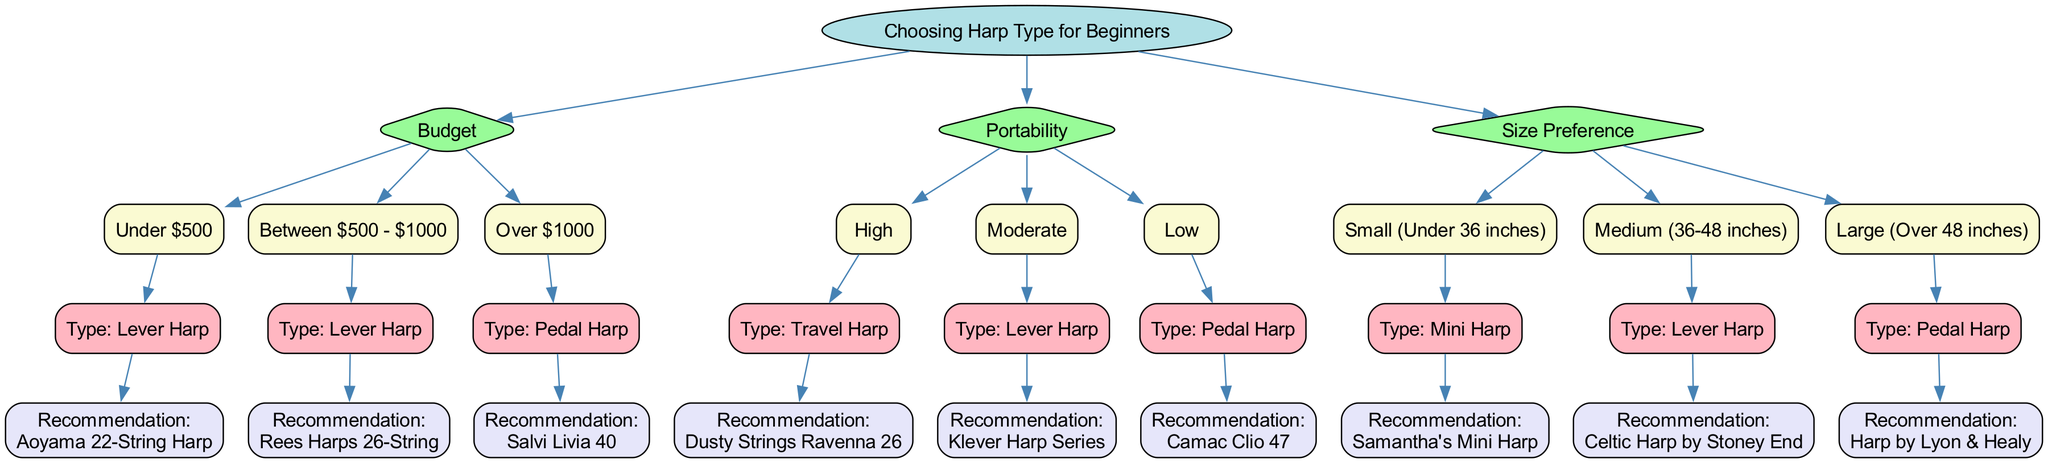What types of harps are recommended for a budget under $500? In the diagram under the "Budget" category, the subcategory "Under $500" leads to the "Lever Harp" type. The recommendation given is the "Aoyama 22-String Harp."
Answer: Lever Harp, Aoyama 22-String Harp What should I choose if I want a highly portable harp? Within the "Portability" category, the "High" subcategory leads to the "Travel Harp" type, and the recommendation is the "Dusty Strings Ravenna 26."
Answer: Travel Harp, Dusty Strings Ravenna 26 How many main categories are there in this decision tree? The diagram starts with the root and has three main categories: "Budget," "Portability," and "Size Preference." Thus, there are three main categories total.
Answer: 3 If I have a size preference of "Large (Over 48 inches)," what type of harp will I get? Looking at the "Size Preference" category, the subcategory "Large (Over 48 inches)" leads to the "Pedal Harp" type, with the recommendation being "Harp by Lyon & Healy."
Answer: Pedal Harp, Harp by Lyon & Healy What type of harp is recommended for a budget between $500 and $1000? The "Budget" category contains the subcategory "Between $500 - $1000," which leads to the "Lever Harp" type, with the recommendation being "Rees Harps 26-String."
Answer: Lever Harp, Rees Harps 26-String What is the relationship between "Moderate" portability and its recommendation? Under the "Portability" category, "Moderate" leads to the "Lever Harp" type, and the recommendation given is "Klever Harp Series," showing a direct connection between the portability level and the harp type.
Answer: Lever Harp, Klever Harp Series Which category leads to the recommendation of the "Salvi Livia 40"? The recommendation for "Salvi Livia 40" comes from the "Budget" category under "Over $1000," which corresponds to the "Pedal Harp" type.
Answer: Budget, Over $1000 How many strings does the "Aoyama 22-String Harp" have? The recommendation for a budget under $500 specifies the "Aoyama 22-String Harp," indicating it has 22 strings.
Answer: 22 strings 